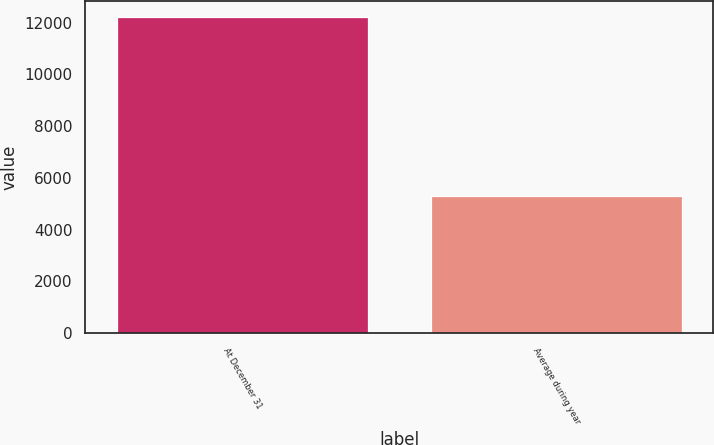Convert chart to OTSL. <chart><loc_0><loc_0><loc_500><loc_500><bar_chart><fcel>At December 31<fcel>Average during year<nl><fcel>12232<fcel>5292<nl></chart> 